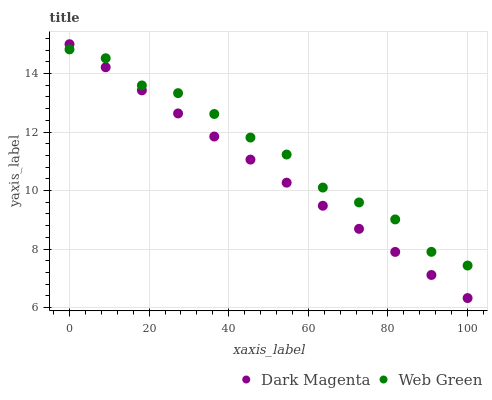Does Dark Magenta have the minimum area under the curve?
Answer yes or no. Yes. Does Web Green have the maximum area under the curve?
Answer yes or no. Yes. Does Web Green have the minimum area under the curve?
Answer yes or no. No. Is Dark Magenta the smoothest?
Answer yes or no. Yes. Is Web Green the roughest?
Answer yes or no. Yes. Is Web Green the smoothest?
Answer yes or no. No. Does Dark Magenta have the lowest value?
Answer yes or no. Yes. Does Web Green have the lowest value?
Answer yes or no. No. Does Dark Magenta have the highest value?
Answer yes or no. Yes. Does Web Green have the highest value?
Answer yes or no. No. Does Web Green intersect Dark Magenta?
Answer yes or no. Yes. Is Web Green less than Dark Magenta?
Answer yes or no. No. Is Web Green greater than Dark Magenta?
Answer yes or no. No. 